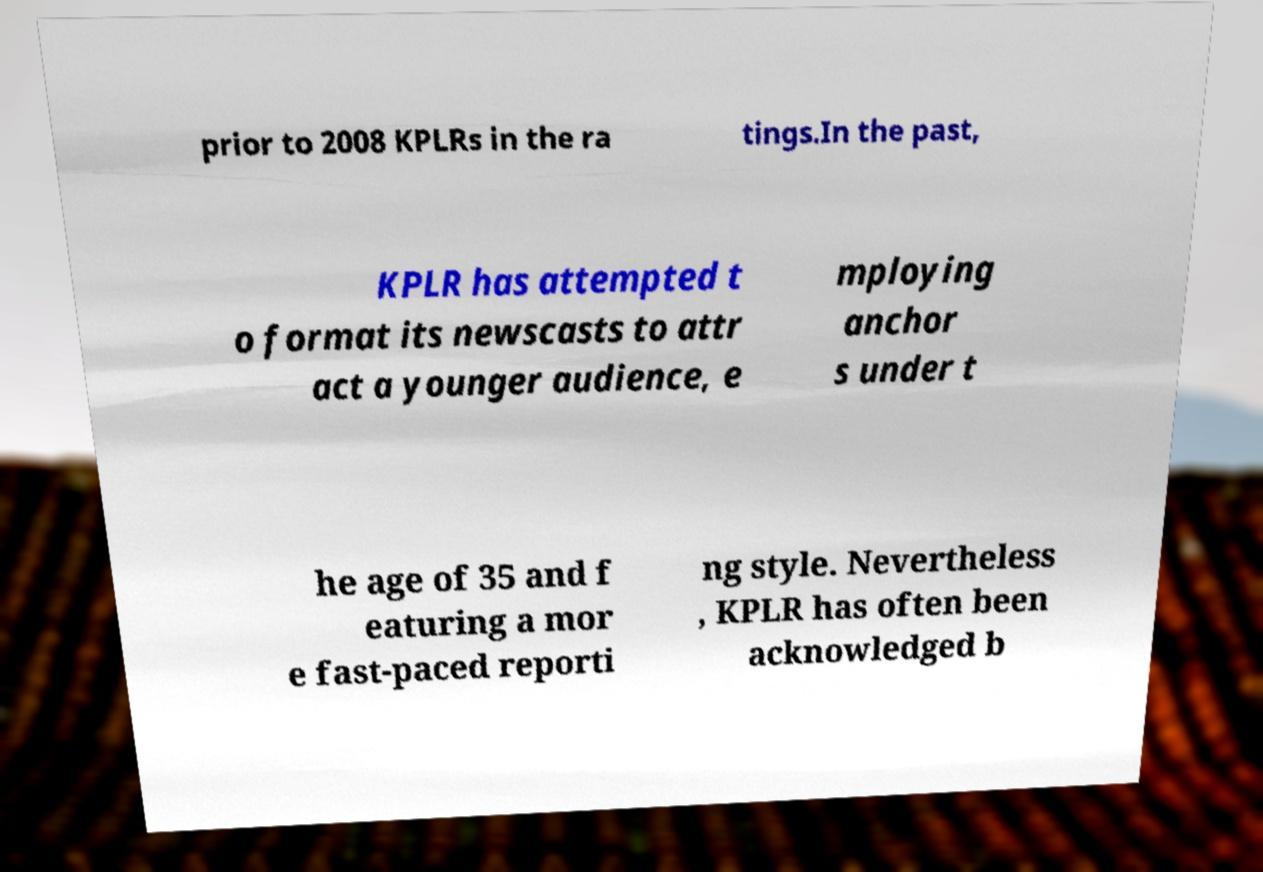For documentation purposes, I need the text within this image transcribed. Could you provide that? prior to 2008 KPLRs in the ra tings.In the past, KPLR has attempted t o format its newscasts to attr act a younger audience, e mploying anchor s under t he age of 35 and f eaturing a mor e fast-paced reporti ng style. Nevertheless , KPLR has often been acknowledged b 